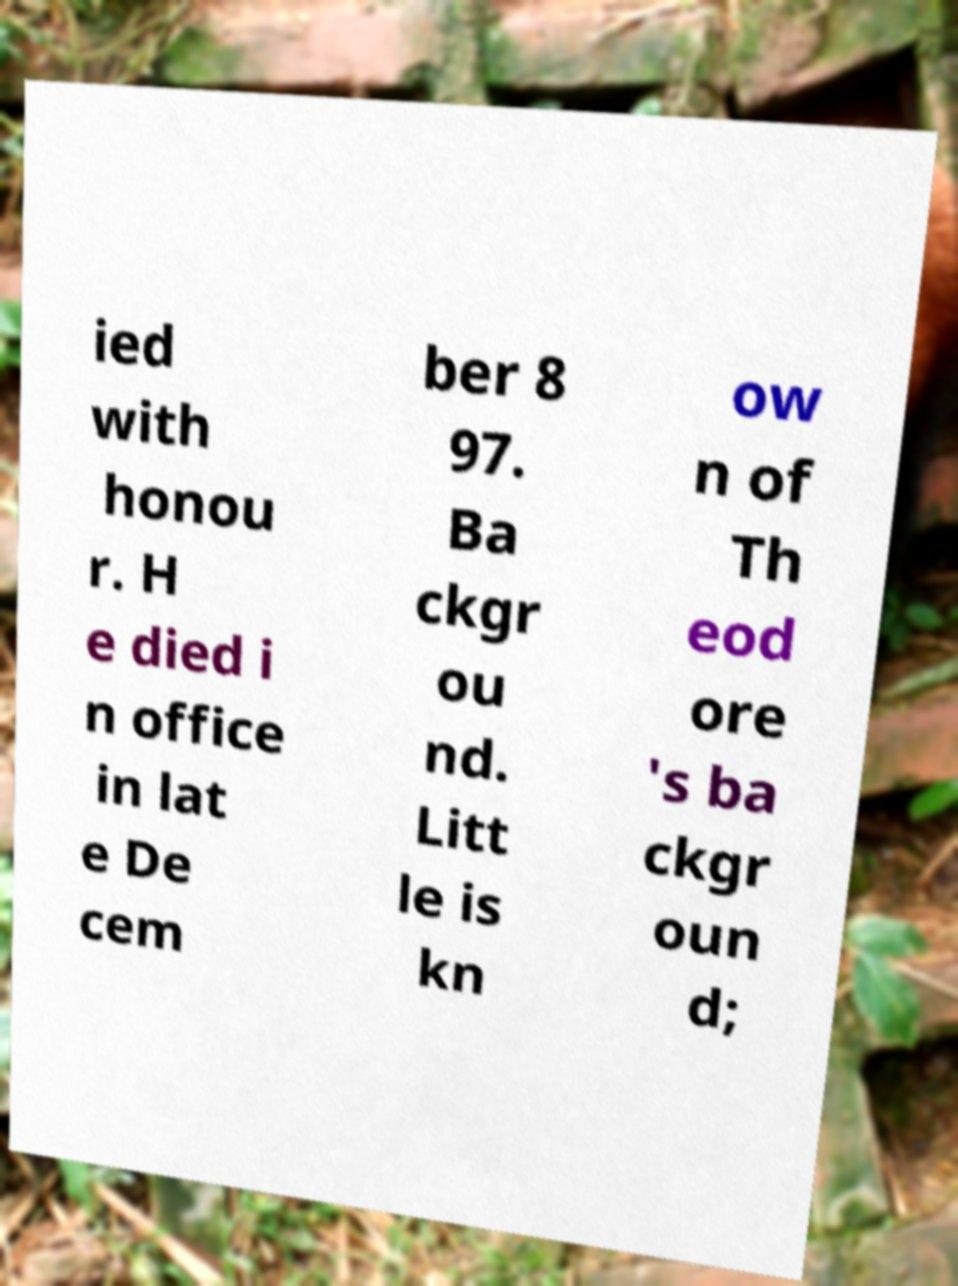For documentation purposes, I need the text within this image transcribed. Could you provide that? ied with honou r. H e died i n office in lat e De cem ber 8 97. Ba ckgr ou nd. Litt le is kn ow n of Th eod ore 's ba ckgr oun d; 